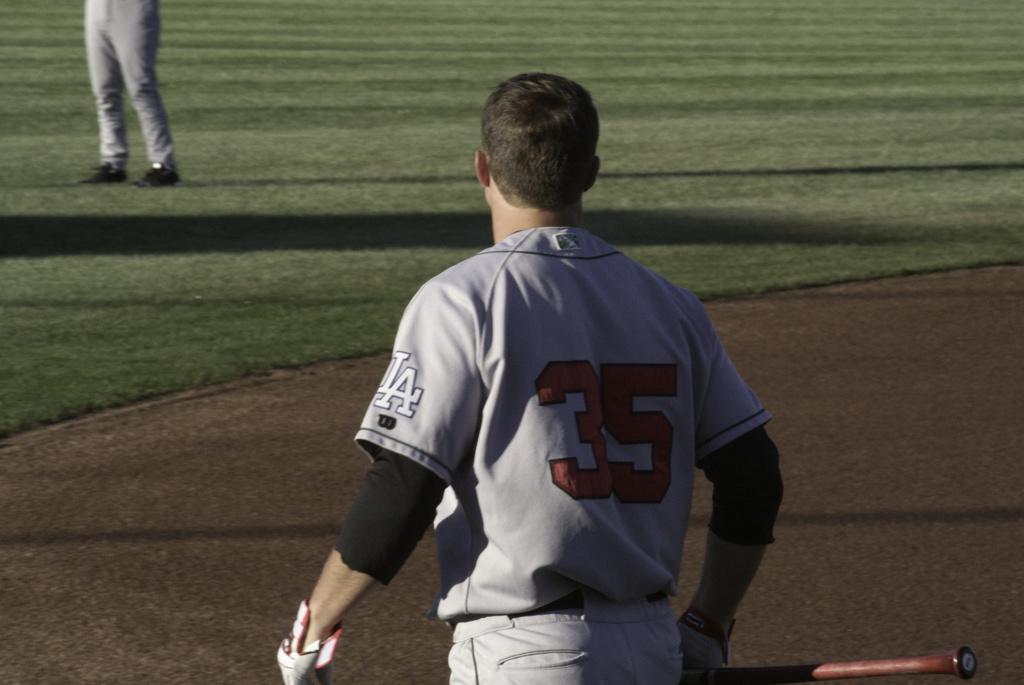What team is on this players sleeve?
Give a very brief answer. La. What is the player number?
Offer a very short reply. 35. 